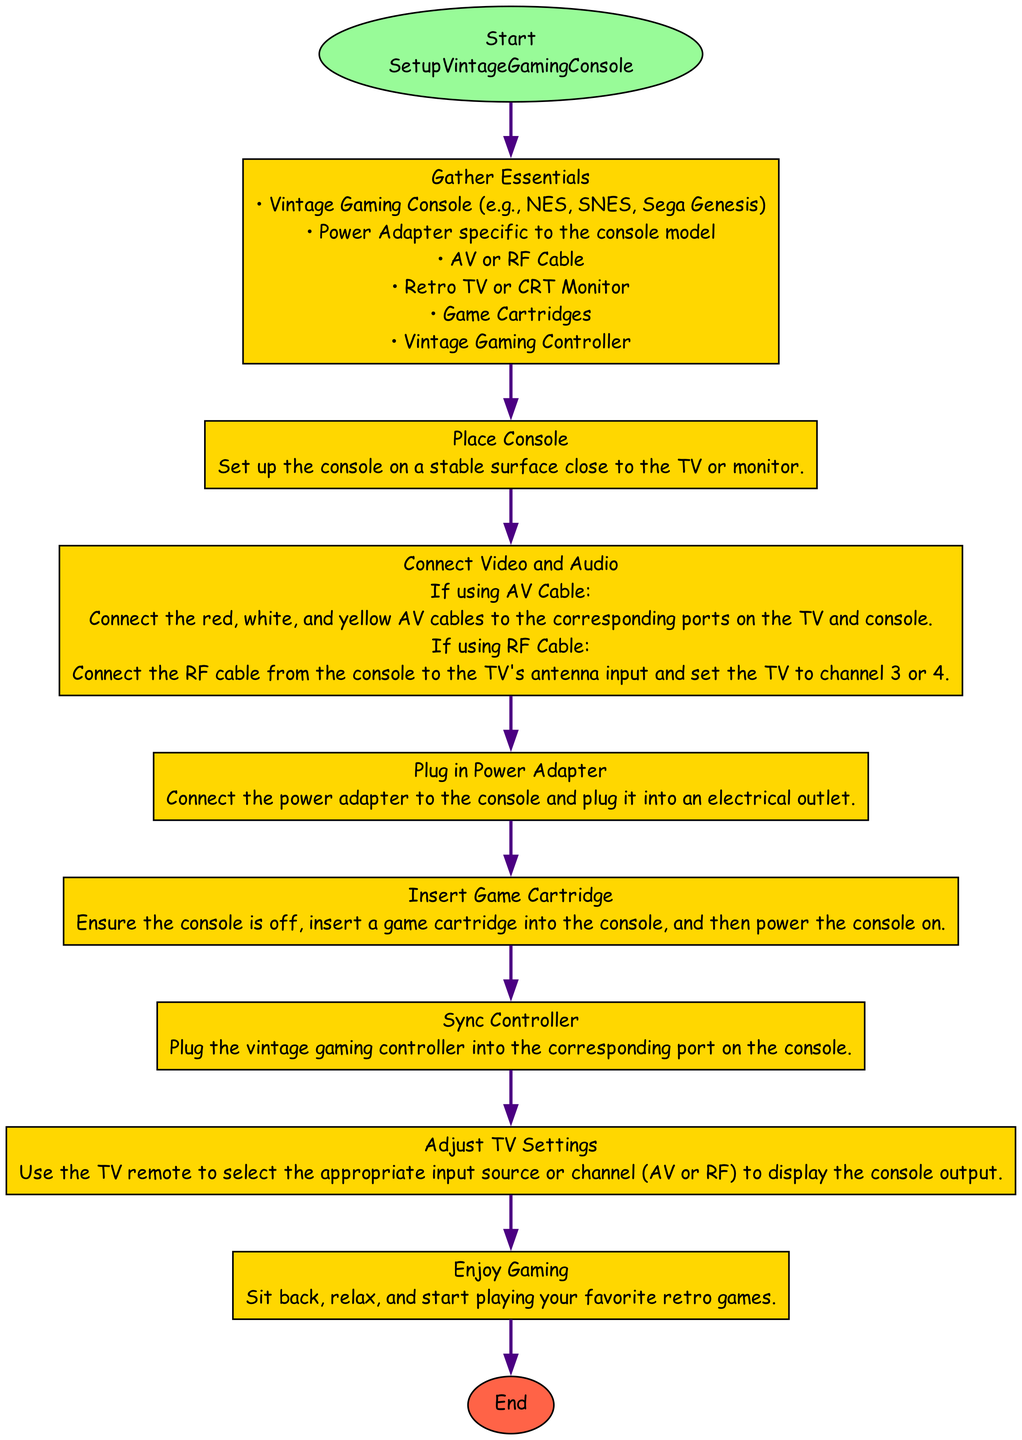What is the first step in setting up the vintage gaming console? The first step in the diagram is labeled "Gather Essentials," which indicates this is the initial action to take before proceeding to other steps.
Answer: Gather Essentials How many items are listed under "Gather Essentials"? By counting the items listed under the "Gather Essentials" step, we see six distinct items mentioned, meaning the count is six.
Answer: 6 What is the instruction given in the "Plug in Power Adapter" step? In the "Plug in Power Adapter" step, the instruction presented is to "Connect the power adapter to the console and plug it into an electrical outlet." This directly states what's required in that step.
Answer: Connect the power adapter to the console and plug it into an electrical outlet Which step follows "Connect Video and Audio"? The flowchart provides a clear connection from "Connect Video and Audio" to "Plug in Power Adapter," indicating that "Plug in Power Adapter" is the next step to follow in sequence.
Answer: Plug in Power Adapter What are the two options for connecting video and audio? The diagram outlines two distinct methods for video and audio connection: "If using AV Cable" and "If using RF Cable." These represent the alternatives available when setting up the console.
Answer: AV Cable and RF Cable What is the final step before enjoying gaming? The step before "Enjoy Gaming" is "Adjust TV Settings," which clarifies that this adjustment must take place to ensure a proper gaming experience.
Answer: Adjust TV Settings What should you do after inserting the game cartridge? The instruction following the insertion of the game cartridge is to "power the console on." This indicates the action that needs to be performed after the cartridge is correctly inserted.
Answer: Power the console on In which step do you sync the controller? The syncing of the controller is addressed in the dedicated step titled "Sync Controller," making it clear where this action is referenced in the flowchart.
Answer: Sync Controller What color are the edges connecting the nodes in the diagram? The edges connecting the nodes are colored purple, as described in the diagram’s edge attributes, indicating the style chosen for the connections.
Answer: Purple 